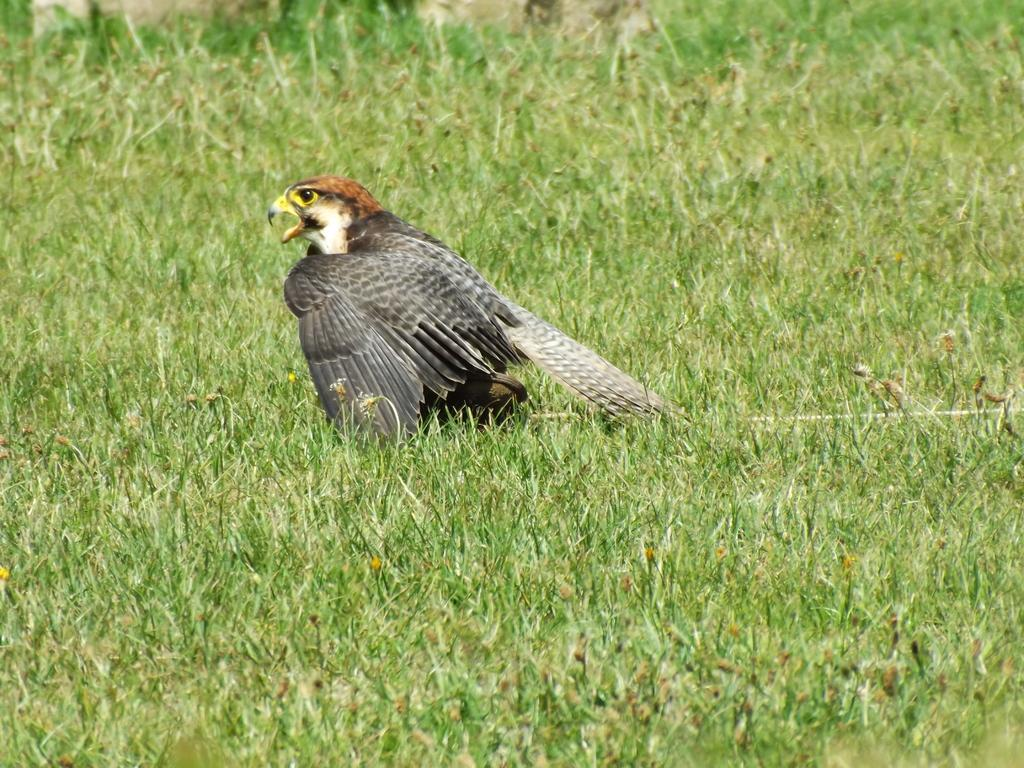What is the main subject in the center of the image? There is a bird in the center of the image. What type of vegetation can be seen at the bottom of the image? There is grass at the bottom of the image. What type of berry is the bird digesting in the image? There is no berry present in the image, and the bird's digestion cannot be observed. 